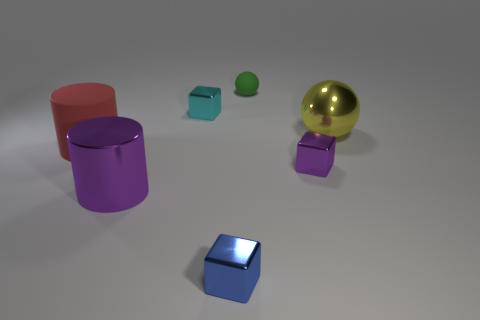There is a purple cube that is the same material as the tiny cyan block; what is its size?
Offer a terse response. Small. What number of other purple things are the same shape as the big rubber thing?
Offer a terse response. 1. What number of big metal balls are there?
Ensure brevity in your answer.  1. There is a matte object that is on the left side of the large shiny cylinder; does it have the same shape as the tiny cyan metallic object?
Ensure brevity in your answer.  No. What material is the yellow sphere that is the same size as the red matte cylinder?
Your answer should be compact. Metal. Is there a small cyan cube that has the same material as the red thing?
Offer a terse response. No. Is the shape of the big purple shiny thing the same as the purple object that is right of the blue shiny block?
Your response must be concise. No. How many shiny things are both to the right of the blue metallic block and on the left side of the metal sphere?
Offer a terse response. 1. Does the green thing have the same material as the small cube behind the large yellow shiny ball?
Offer a terse response. No. Are there an equal number of green objects in front of the tiny green rubber object and small cyan objects?
Ensure brevity in your answer.  No. 